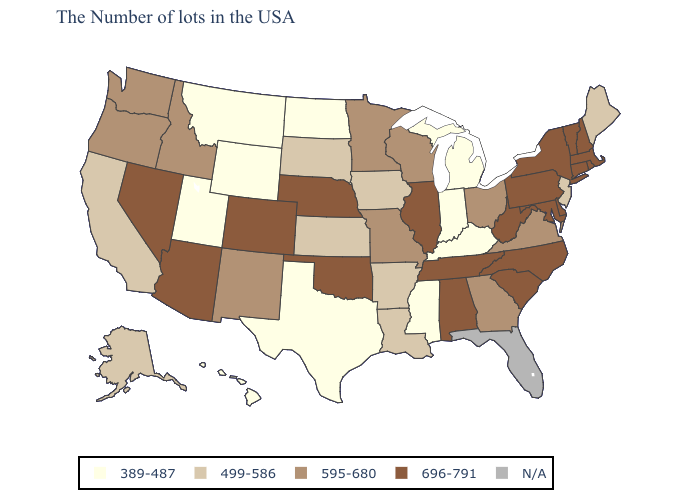Which states have the highest value in the USA?
Give a very brief answer. Massachusetts, Rhode Island, New Hampshire, Vermont, Connecticut, New York, Delaware, Maryland, Pennsylvania, North Carolina, South Carolina, West Virginia, Alabama, Tennessee, Illinois, Nebraska, Oklahoma, Colorado, Arizona, Nevada. Which states have the highest value in the USA?
Give a very brief answer. Massachusetts, Rhode Island, New Hampshire, Vermont, Connecticut, New York, Delaware, Maryland, Pennsylvania, North Carolina, South Carolina, West Virginia, Alabama, Tennessee, Illinois, Nebraska, Oklahoma, Colorado, Arizona, Nevada. What is the highest value in states that border Arizona?
Keep it brief. 696-791. What is the value of Alabama?
Short answer required. 696-791. Does Alabama have the highest value in the USA?
Quick response, please. Yes. What is the value of Alabama?
Answer briefly. 696-791. How many symbols are there in the legend?
Quick response, please. 5. Which states have the highest value in the USA?
Write a very short answer. Massachusetts, Rhode Island, New Hampshire, Vermont, Connecticut, New York, Delaware, Maryland, Pennsylvania, North Carolina, South Carolina, West Virginia, Alabama, Tennessee, Illinois, Nebraska, Oklahoma, Colorado, Arizona, Nevada. Does Massachusetts have the highest value in the USA?
Concise answer only. Yes. What is the value of South Dakota?
Write a very short answer. 499-586. Name the states that have a value in the range 389-487?
Answer briefly. Michigan, Kentucky, Indiana, Mississippi, Texas, North Dakota, Wyoming, Utah, Montana, Hawaii. Name the states that have a value in the range 389-487?
Concise answer only. Michigan, Kentucky, Indiana, Mississippi, Texas, North Dakota, Wyoming, Utah, Montana, Hawaii. Name the states that have a value in the range 499-586?
Concise answer only. Maine, New Jersey, Louisiana, Arkansas, Iowa, Kansas, South Dakota, California, Alaska. Which states hav the highest value in the South?
Keep it brief. Delaware, Maryland, North Carolina, South Carolina, West Virginia, Alabama, Tennessee, Oklahoma. 